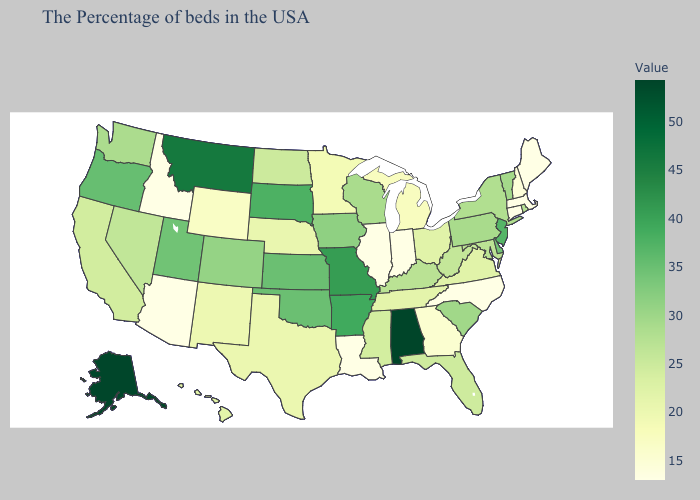Among the states that border Oklahoma , which have the highest value?
Write a very short answer. Missouri. Does Indiana have a higher value than Delaware?
Give a very brief answer. No. Which states hav the highest value in the South?
Quick response, please. Alabama. Which states have the highest value in the USA?
Give a very brief answer. Alabama. Does Kansas have a lower value than Texas?
Short answer required. No. 